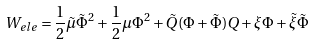<formula> <loc_0><loc_0><loc_500><loc_500>W _ { e l e } = \frac { 1 } { 2 } \tilde { \mu } \tilde { \Phi } ^ { 2 } + \frac { 1 } { 2 } \mu \Phi ^ { 2 } + \tilde { Q } ( \Phi + \tilde { \Phi } ) Q + \xi \Phi + \tilde { \xi } \tilde { \Phi }</formula> 